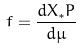<formula> <loc_0><loc_0><loc_500><loc_500>f = \frac { d X _ { * } P } { d \mu }</formula> 